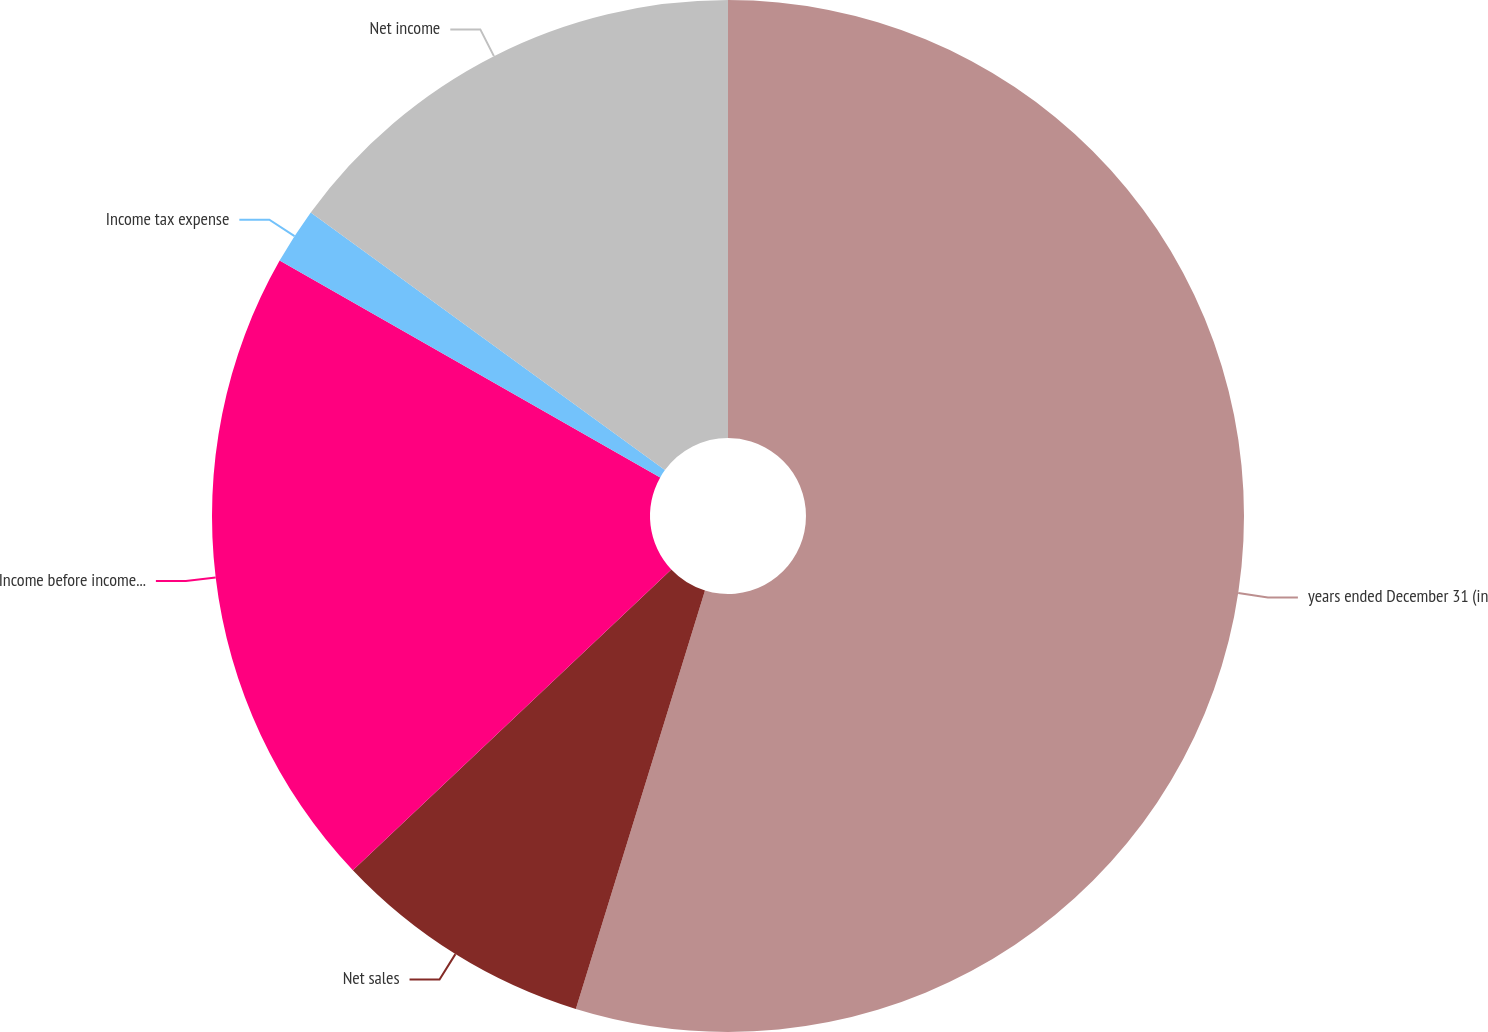Convert chart to OTSL. <chart><loc_0><loc_0><loc_500><loc_500><pie_chart><fcel>years ended December 31 (in<fcel>Net sales<fcel>Income before income taxes<fcel>Income tax expense<fcel>Net income<nl><fcel>54.77%<fcel>8.19%<fcel>20.29%<fcel>1.77%<fcel>14.99%<nl></chart> 